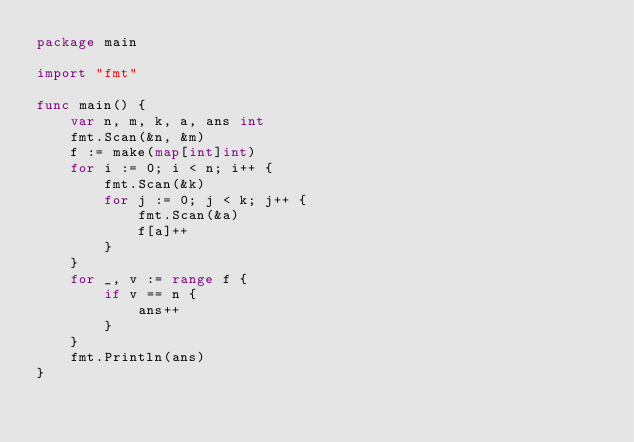Convert code to text. <code><loc_0><loc_0><loc_500><loc_500><_Go_>package main

import "fmt"

func main() {
	var n, m, k, a, ans int
	fmt.Scan(&n, &m)
	f := make(map[int]int)
	for i := 0; i < n; i++ {
		fmt.Scan(&k)
		for j := 0; j < k; j++ {
			fmt.Scan(&a)
			f[a]++
		}
	}
	for _, v := range f {
		if v == n {
			ans++
		}
	}
	fmt.Println(ans)
}
</code> 